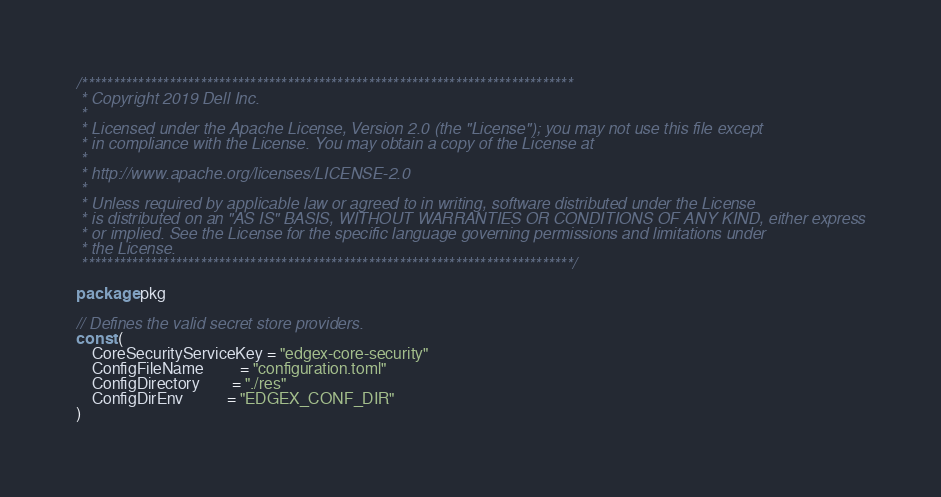<code> <loc_0><loc_0><loc_500><loc_500><_Go_>/*******************************************************************************
 * Copyright 2019 Dell Inc.
 *
 * Licensed under the Apache License, Version 2.0 (the "License"); you may not use this file except
 * in compliance with the License. You may obtain a copy of the License at
 *
 * http://www.apache.org/licenses/LICENSE-2.0
 *
 * Unless required by applicable law or agreed to in writing, software distributed under the License
 * is distributed on an "AS IS" BASIS, WITHOUT WARRANTIES OR CONDITIONS OF ANY KIND, either express
 * or implied. See the License for the specific language governing permissions and limitations under
 * the License.
 *******************************************************************************/

package pkg

// Defines the valid secret store providers.
const (
	CoreSecurityServiceKey = "edgex-core-security"
	ConfigFileName         = "configuration.toml"
	ConfigDirectory        = "./res"
	ConfigDirEnv           = "EDGEX_CONF_DIR"
)
</code> 